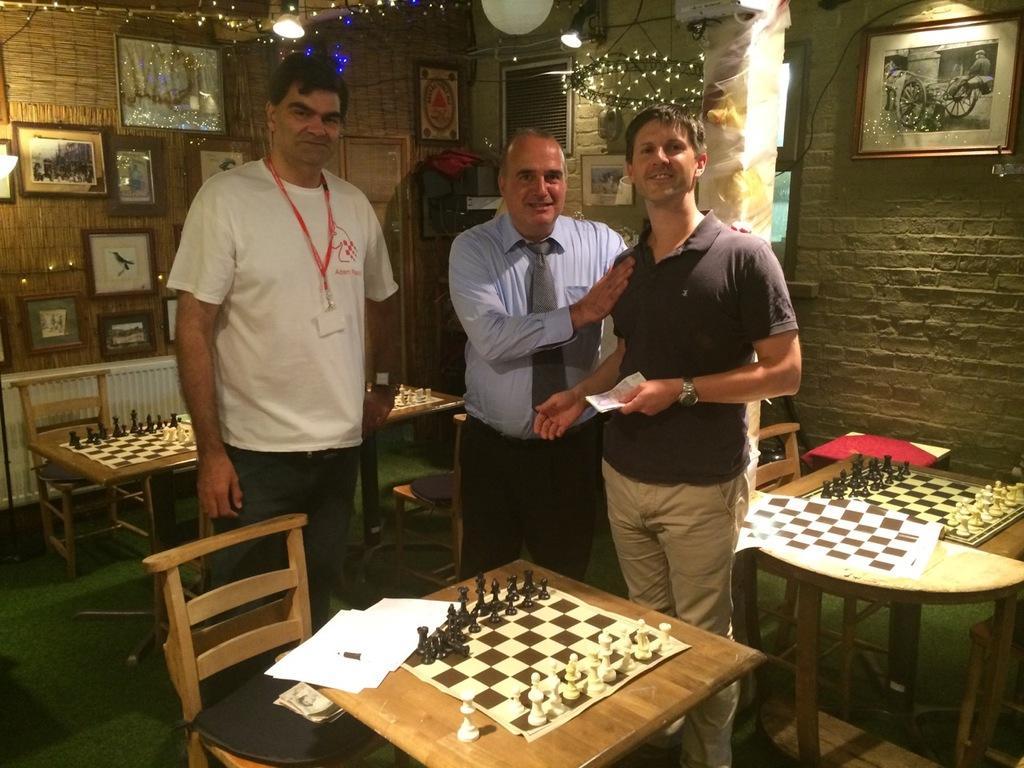How would you summarize this image in a sentence or two? In this image there are three persons who are standing and there are chess boards around them and at the top of the image there are sceneries attached to the wall. 